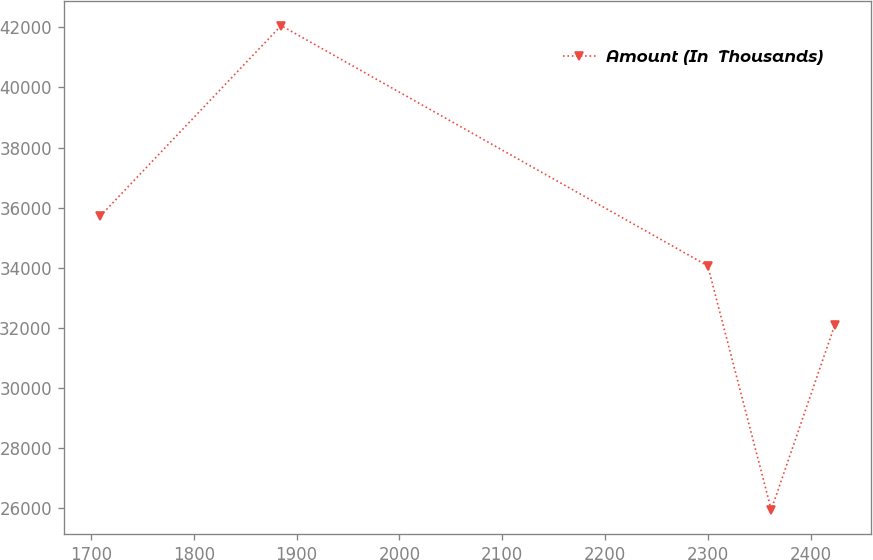Convert chart. <chart><loc_0><loc_0><loc_500><loc_500><line_chart><ecel><fcel>Amount (In  Thousands)<nl><fcel>1708.96<fcel>35722.1<nl><fcel>1884.93<fcel>42061.5<nl><fcel>2300.03<fcel>34062.4<nl><fcel>2361.77<fcel>25942.1<nl><fcel>2423.51<fcel>32088.6<nl></chart> 